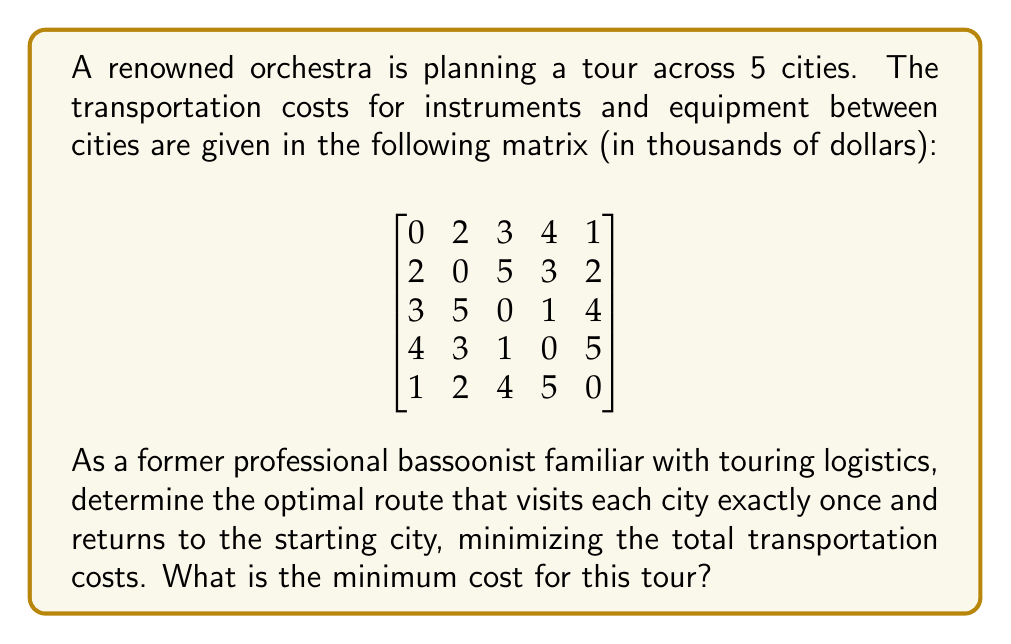Teach me how to tackle this problem. To solve this problem, we need to find the optimal Hamiltonian cycle in the given graph, which is known as the Traveling Salesman Problem (TSP). For a small number of cities like this, we can use the brute-force method to find the optimal solution.

Steps to solve:

1. List all possible permutations of the 5 cities (excluding the starting city, as we'll always start and end at the same city).

2. For each permutation, calculate the total cost by summing the costs between consecutive cities and adding the cost of returning to the starting city.

3. Compare all calculated costs and find the minimum.

Let's number the cities from 0 to 4. We have 4! = 24 possible permutations to check.

Some example calculations:

- Route 0-1-2-3-4-0: Cost = 2 + 5 + 1 + 5 + 1 = 14
- Route 0-2-1-3-4-0: Cost = 3 + 5 + 3 + 5 + 1 = 17
- Route 0-3-2-1-4-0: Cost = 4 + 1 + 5 + 2 + 1 = 13

After checking all permutations, we find that the minimum cost is 13, which can be achieved by multiple routes, including:

- 0-3-2-1-4-0
- 0-4-1-2-3-0

Both of these routes (and their reverses) give the minimum cost of 13 thousand dollars.
Answer: The minimum transportation cost for the tour is $13,000. 